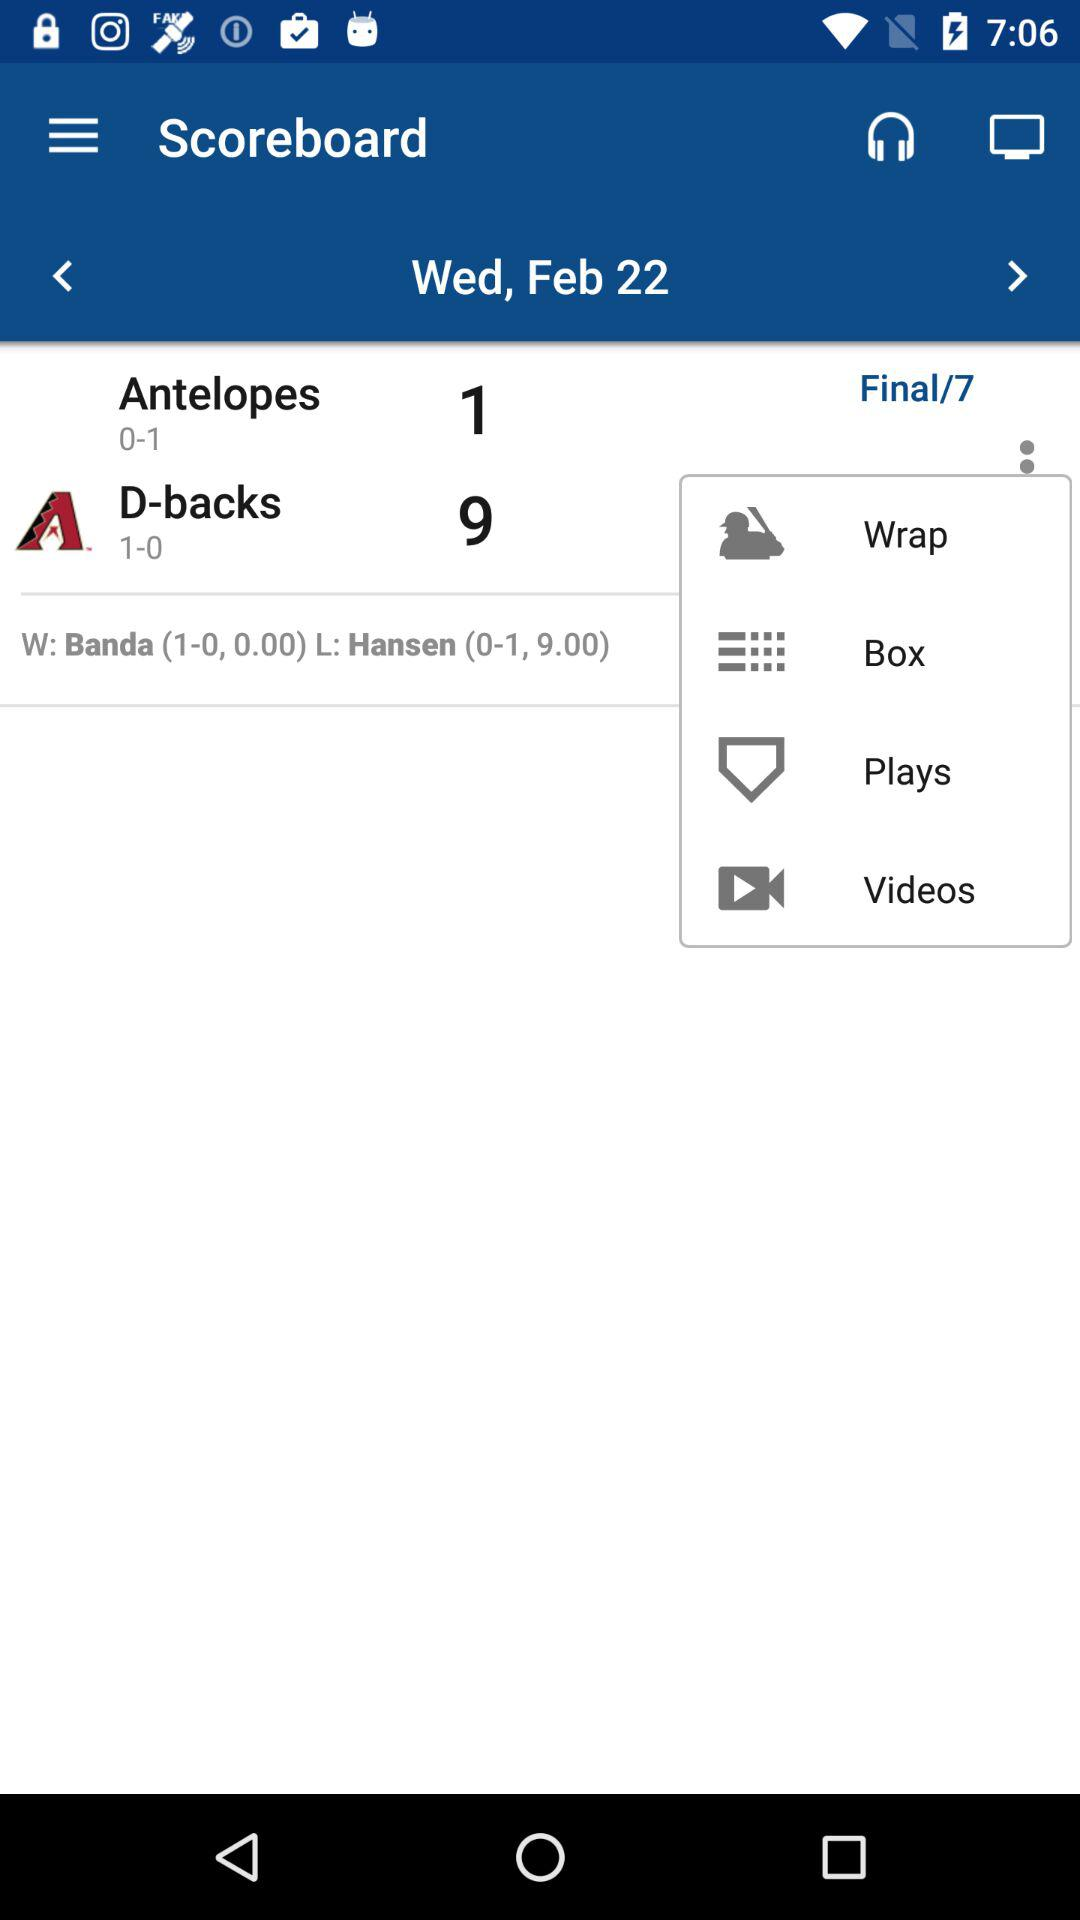How many runs did "Antelopes" score? "Antelopes" scored 1 run. 